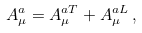Convert formula to latex. <formula><loc_0><loc_0><loc_500><loc_500>A _ { \mu } ^ { a } = A _ { \mu } ^ { a T } + A _ { \mu } ^ { a L } \, ,</formula> 